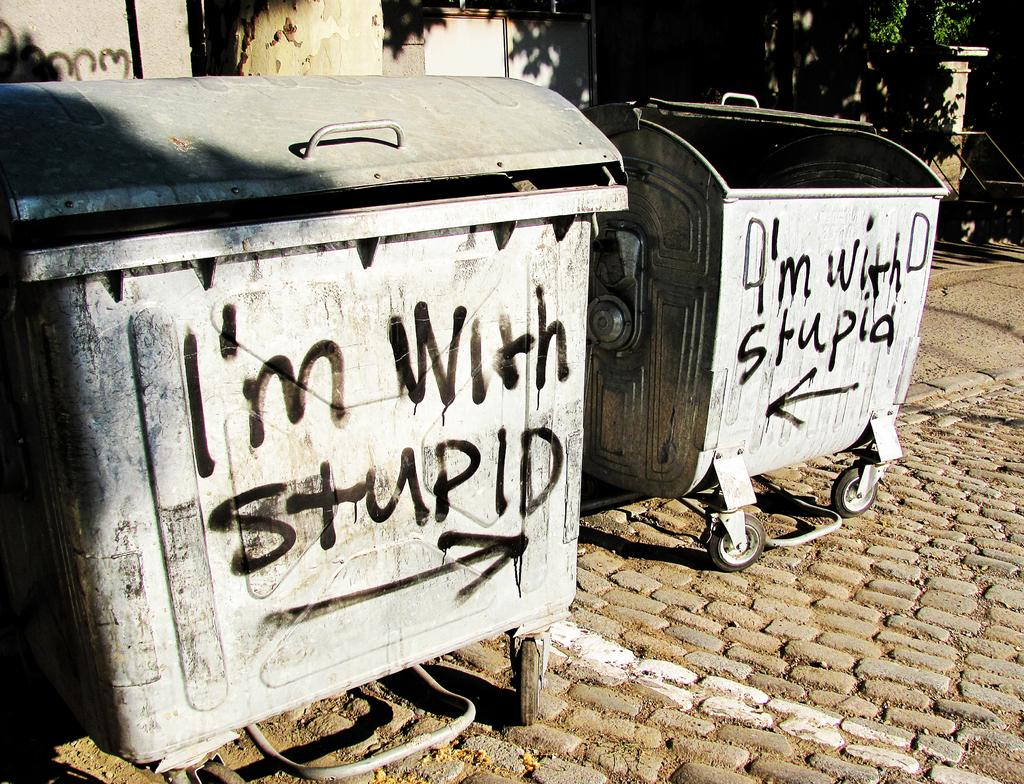Provide a one-sentence caption for the provided image. A container is sprayed painted in black that reads, "I'm with stupid.". 